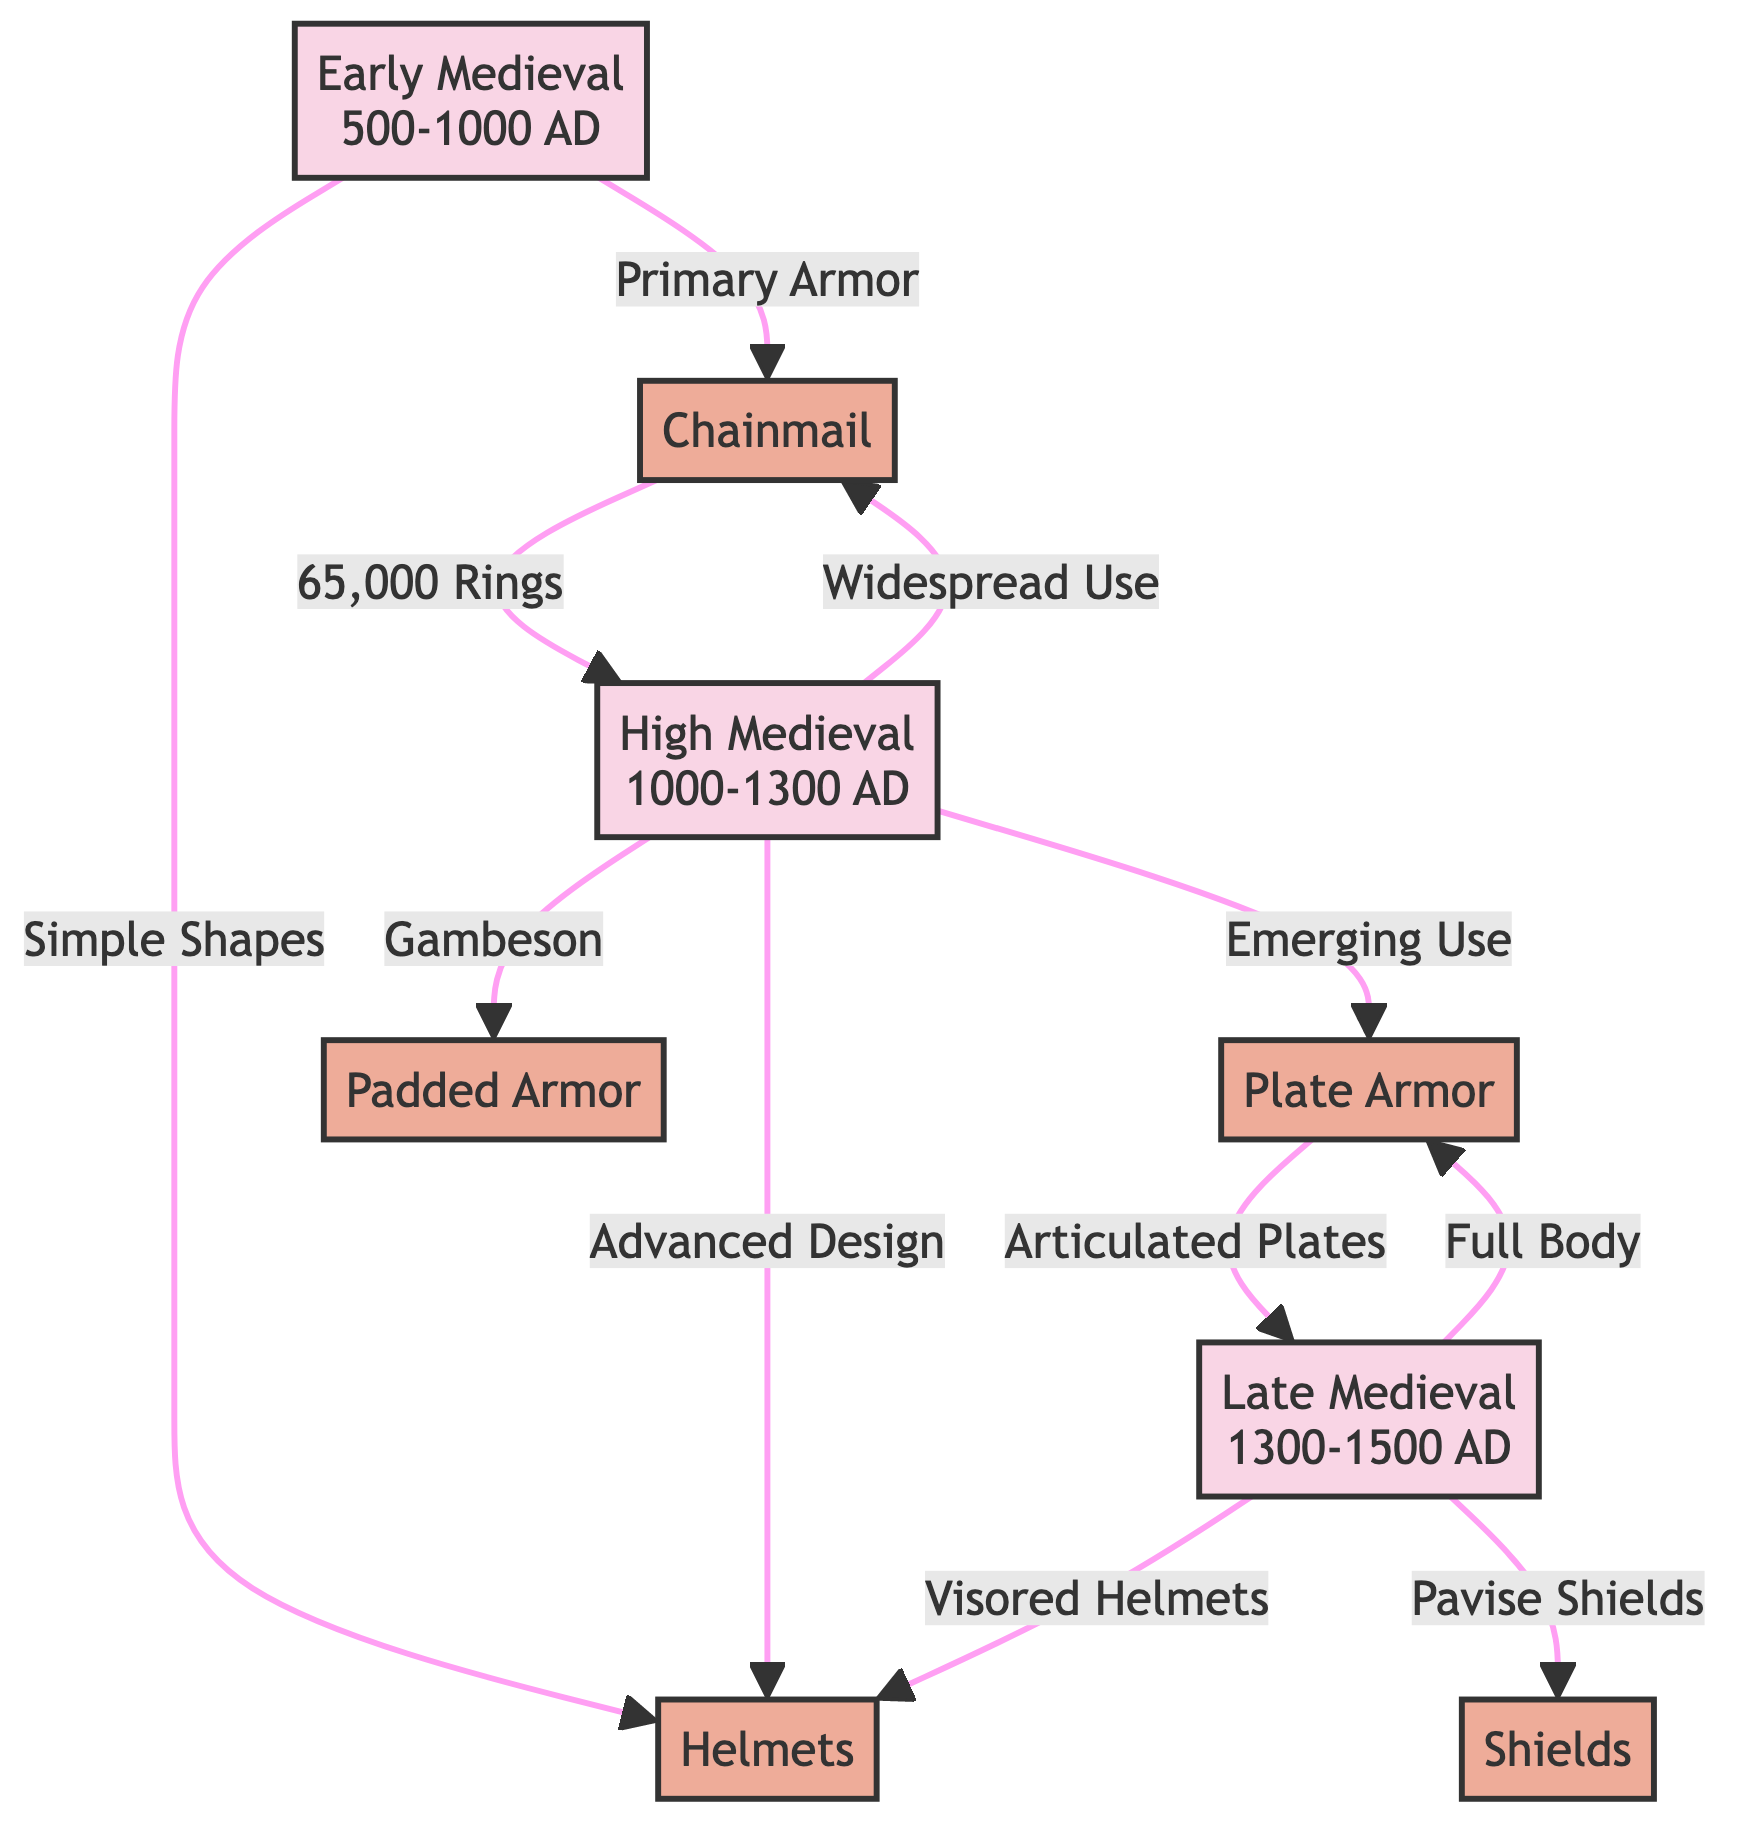What is the primary armor used in the Early Medieval period? The diagram indicates that the primary armor in the Early Medieval period is Chainmail, as shown by the arrow connecting Early Medieval to Chainmail.
Answer: Chainmail What armor is associated with the Late Medieval period? The diagram reveals that the Late Medieval period is associated with Plate Armor, as denoted by the arrow from Late Medieval to Plate Armor.
Answer: Plate Armor How many rings are indicated for a Chainmail in the High Medieval period? The diagram specifies that there are 65,000 rings related to Chainmail in the High Medieval period, pointed out by the arrow from Chainmail to High Medieval with the label.
Answer: 65,000 Rings What armor type is mentioned under High Medieval as an emerging use? According to the diagram, the emerging use of armor in the High Medieval period is Plate Armor, as the arrow from High Medieval points to Plate Armor with that label.
Answer: Plate Armor Which type of helmet is used in the Late Medieval period? The diagram clearly states that the Late Medieval period features Visored Helmets, as shown by the connection from Late Medieval to Visored Helmets.
Answer: Visored Helmets What type of shield is represented in the Late Medieval period? The diagram indicates that Pavise Shields are the type of shield associated with the Late Medieval period, as indicated by the arrow from Late Medieval to Pavise Shields.
Answer: Pavise Shields What armor is used in the High Medieval period that utilizes a Gambeson? The diagram indicates that in the High Medieval period, Padded Armor is utilized along with a Gambeson, as the label points to Padded Armor from High Medieval.
Answer: Padded Armor How does the early medieval armor compare to the late medieval in terms of coverage? The diagram illustrates that Early Medieval armor focuses on Chainmail, which contrasts with Late Medieval armor employing Full Body Plate Armor, indicating an evolution in armor coverage from basic to comprehensive.
Answer: Full Body What is the primary characteristic of the helmets in the High Medieval period? The diagram indicates that helmets in the High Medieval period exhibit Advanced Design, as indicated by the arrow from High Medieval to Helmets with that label.
Answer: Advanced Design 